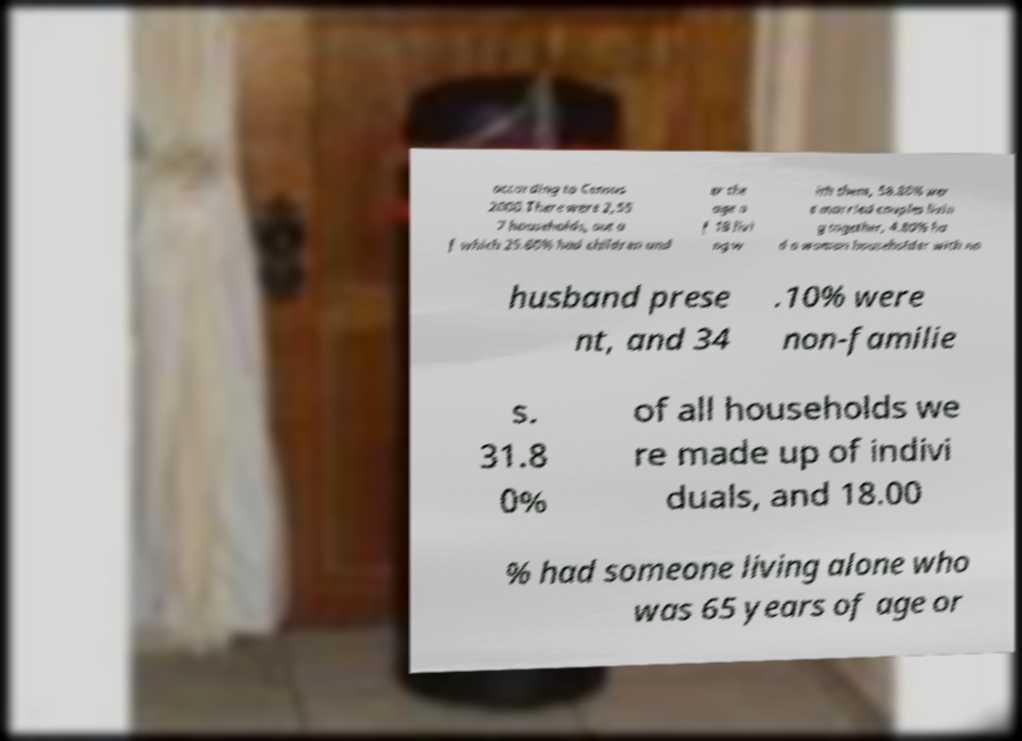Please read and relay the text visible in this image. What does it say? according to Census 2000.There were 2,55 7 households, out o f which 25.60% had children und er the age o f 18 livi ng w ith them, 58.80% wer e married couples livin g together, 4.80% ha d a woman householder with no husband prese nt, and 34 .10% were non-familie s. 31.8 0% of all households we re made up of indivi duals, and 18.00 % had someone living alone who was 65 years of age or 